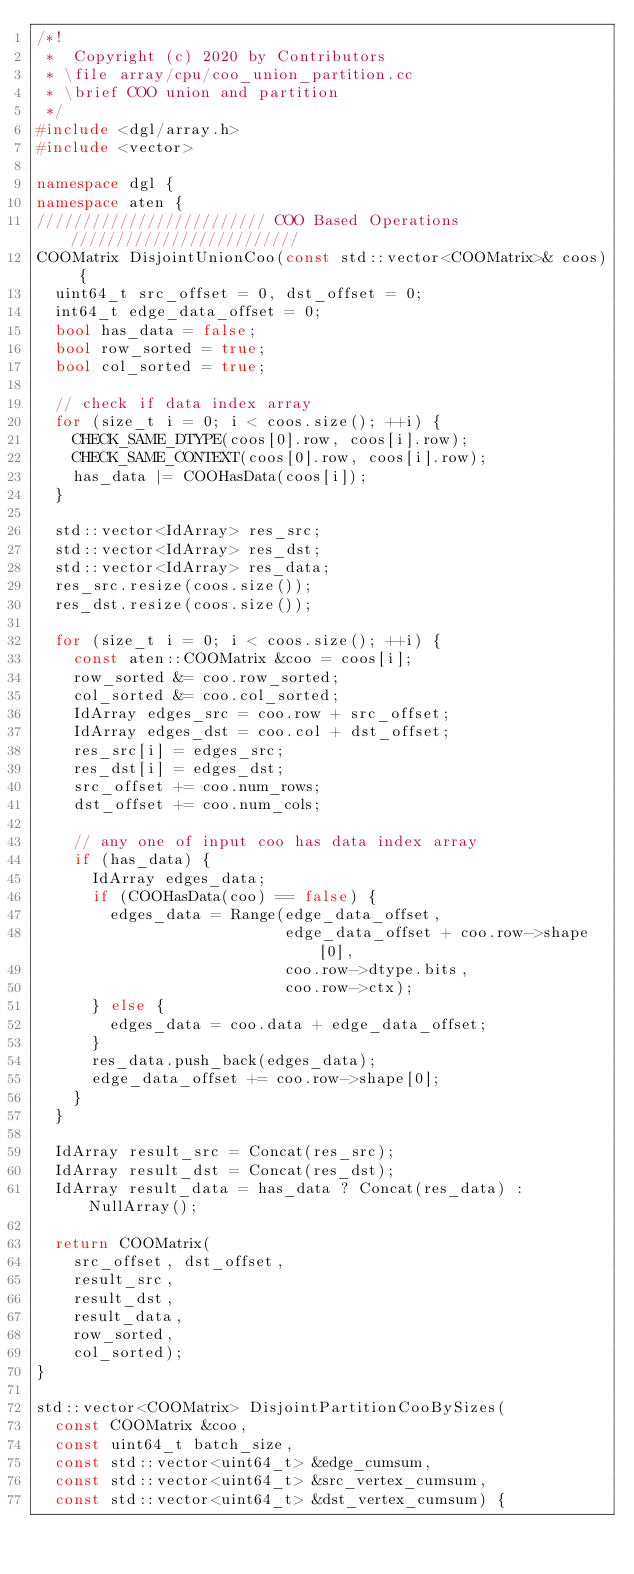<code> <loc_0><loc_0><loc_500><loc_500><_C++_>/*!
 *  Copyright (c) 2020 by Contributors
 * \file array/cpu/coo_union_partition.cc
 * \brief COO union and partition
 */
#include <dgl/array.h>
#include <vector>

namespace dgl {
namespace aten {
///////////////////////// COO Based Operations/////////////////////////
COOMatrix DisjointUnionCoo(const std::vector<COOMatrix>& coos) {
  uint64_t src_offset = 0, dst_offset = 0;
  int64_t edge_data_offset = 0;
  bool has_data = false;
  bool row_sorted = true;
  bool col_sorted = true;

  // check if data index array
  for (size_t i = 0; i < coos.size(); ++i) {
    CHECK_SAME_DTYPE(coos[0].row, coos[i].row);
    CHECK_SAME_CONTEXT(coos[0].row, coos[i].row);
    has_data |= COOHasData(coos[i]);
  }

  std::vector<IdArray> res_src;
  std::vector<IdArray> res_dst;
  std::vector<IdArray> res_data;
  res_src.resize(coos.size());
  res_dst.resize(coos.size());

  for (size_t i = 0; i < coos.size(); ++i) {
    const aten::COOMatrix &coo = coos[i];
    row_sorted &= coo.row_sorted;
    col_sorted &= coo.col_sorted;
    IdArray edges_src = coo.row + src_offset;
    IdArray edges_dst = coo.col + dst_offset;
    res_src[i] = edges_src;
    res_dst[i] = edges_dst;
    src_offset += coo.num_rows;
    dst_offset += coo.num_cols;

    // any one of input coo has data index array
    if (has_data) {
      IdArray edges_data;
      if (COOHasData(coo) == false) {
        edges_data = Range(edge_data_offset,
                           edge_data_offset + coo.row->shape[0],
                           coo.row->dtype.bits,
                           coo.row->ctx);
      } else {
        edges_data = coo.data + edge_data_offset;
      }
      res_data.push_back(edges_data);
      edge_data_offset += coo.row->shape[0];
    }
  }

  IdArray result_src = Concat(res_src);
  IdArray result_dst = Concat(res_dst);
  IdArray result_data = has_data ? Concat(res_data) : NullArray();

  return COOMatrix(
    src_offset, dst_offset,
    result_src,
    result_dst,
    result_data,
    row_sorted,
    col_sorted);
}

std::vector<COOMatrix> DisjointPartitionCooBySizes(
  const COOMatrix &coo,
  const uint64_t batch_size,
  const std::vector<uint64_t> &edge_cumsum,
  const std::vector<uint64_t> &src_vertex_cumsum,
  const std::vector<uint64_t> &dst_vertex_cumsum) {</code> 